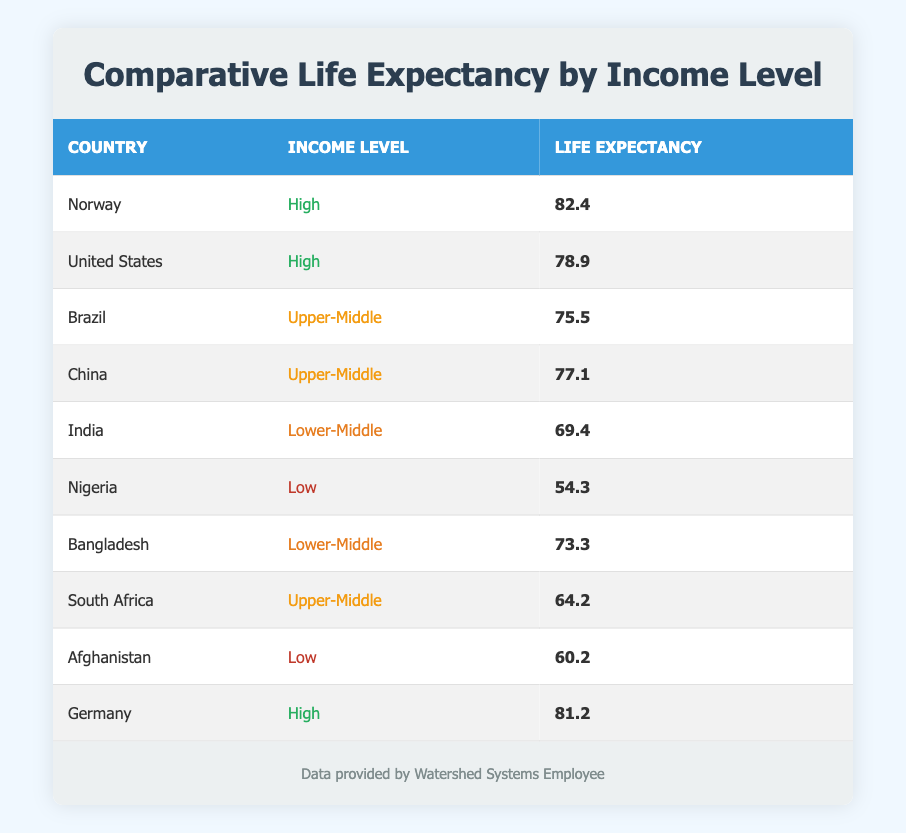What is the life expectancy in Norway? In the table, Norway is listed with a life expectancy of 82.4 years. This information is directly retrievable from the table without the need for calculation or interpretation.
Answer: 82.4 Which country has the lowest life expectancy? The data shows Nigeria with a life expectancy of 54.3 years, which is the lowest among all the countries listed in the table. This can be verified by comparing the life expectancy values of each country.
Answer: Nigeria What is the life expectancy of countries at the upper-middle income level? The table lists the life expectancy for Brazil (75.5 years), China (77.1 years), and South Africa (64.2 years) as the upper-middle income countries. To find their average, we calculate (75.5 + 77.1 + 64.2) / 3 = 72.3 years.
Answer: 72.3 Is the life expectancy of India higher than that of Nigeria? According to the data, India has a life expectancy of 69.4 years, while Nigeria has a life expectancy of 54.3 years. Since 69.4 is greater than 54.3, India does have a higher life expectancy than Nigeria.
Answer: Yes What is the difference in life expectancy between the highest and the lowest income levels shown? The highest life expectancy is from Norway at 82.4 years and the lowest from Nigeria at 54.3 years. To calculate the difference: 82.4 - 54.3 = 28.1 years. This shows the gap in life expectancy based on income levels.
Answer: 28.1 Do any countries with a high-income level have a life expectancy below 80 years? The United States is the only high-income country listed, and its life expectancy is 78.9 years. Since this value is indeed below 80, the answer to the question is verified as true.
Answer: Yes What is the average life expectancy of countries in the high-income level category? The high-income countries listed are Norway (82.4 years), the United States (78.9 years), and Germany (81.2 years). To find the average, we calculate (82.4 + 78.9 + 81.2) / 3 = 80.8 years. This gives us insight into life expectancy amongst high-income nations.
Answer: 80.8 What percentage of the listed countries have a life expectancy above 75 years? Counting the countries with life expectancy above 75 years gives us Norway, the United States, China, and Brazil. That's 4 countries out of 10 total. The percentage is (4 / 10) * 100 = 40%. This indicates a significant portion of countries with better life expectancies.
Answer: 40% 